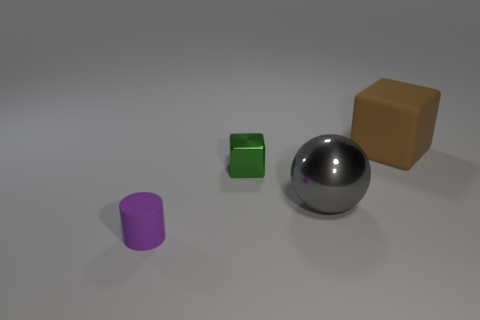Add 4 large blue matte balls. How many objects exist? 8 Subtract all cylinders. How many objects are left? 3 Subtract 0 yellow balls. How many objects are left? 4 Subtract all blocks. Subtract all small metallic objects. How many objects are left? 1 Add 4 large gray metal things. How many large gray metal things are left? 5 Add 2 red metallic things. How many red metallic things exist? 2 